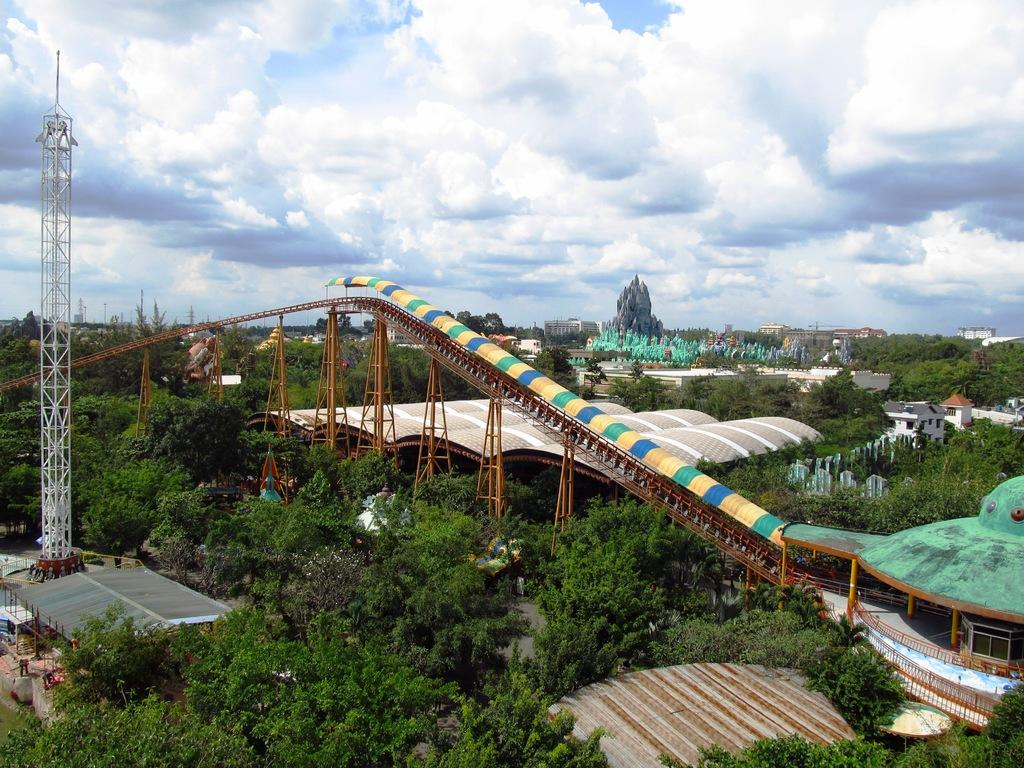What type of natural elements can be seen in the image? There are trees in the image. What type of man-made structures can be seen in the image? There are buildings, sheds, and towers in the image. What type of infrastructure is present in the image? There is a bridge in the image. What is visible in the background of the image? The sky is visible in the background of the image. What can be observed in the sky in the image? Clouds are present in the sky. What type of crime is being committed in the image? There is no indication of any crime being committed in the image. What is the stick used for in the image? There is no stick present in the image. 